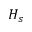Convert formula to latex. <formula><loc_0><loc_0><loc_500><loc_500>H _ { s }</formula> 